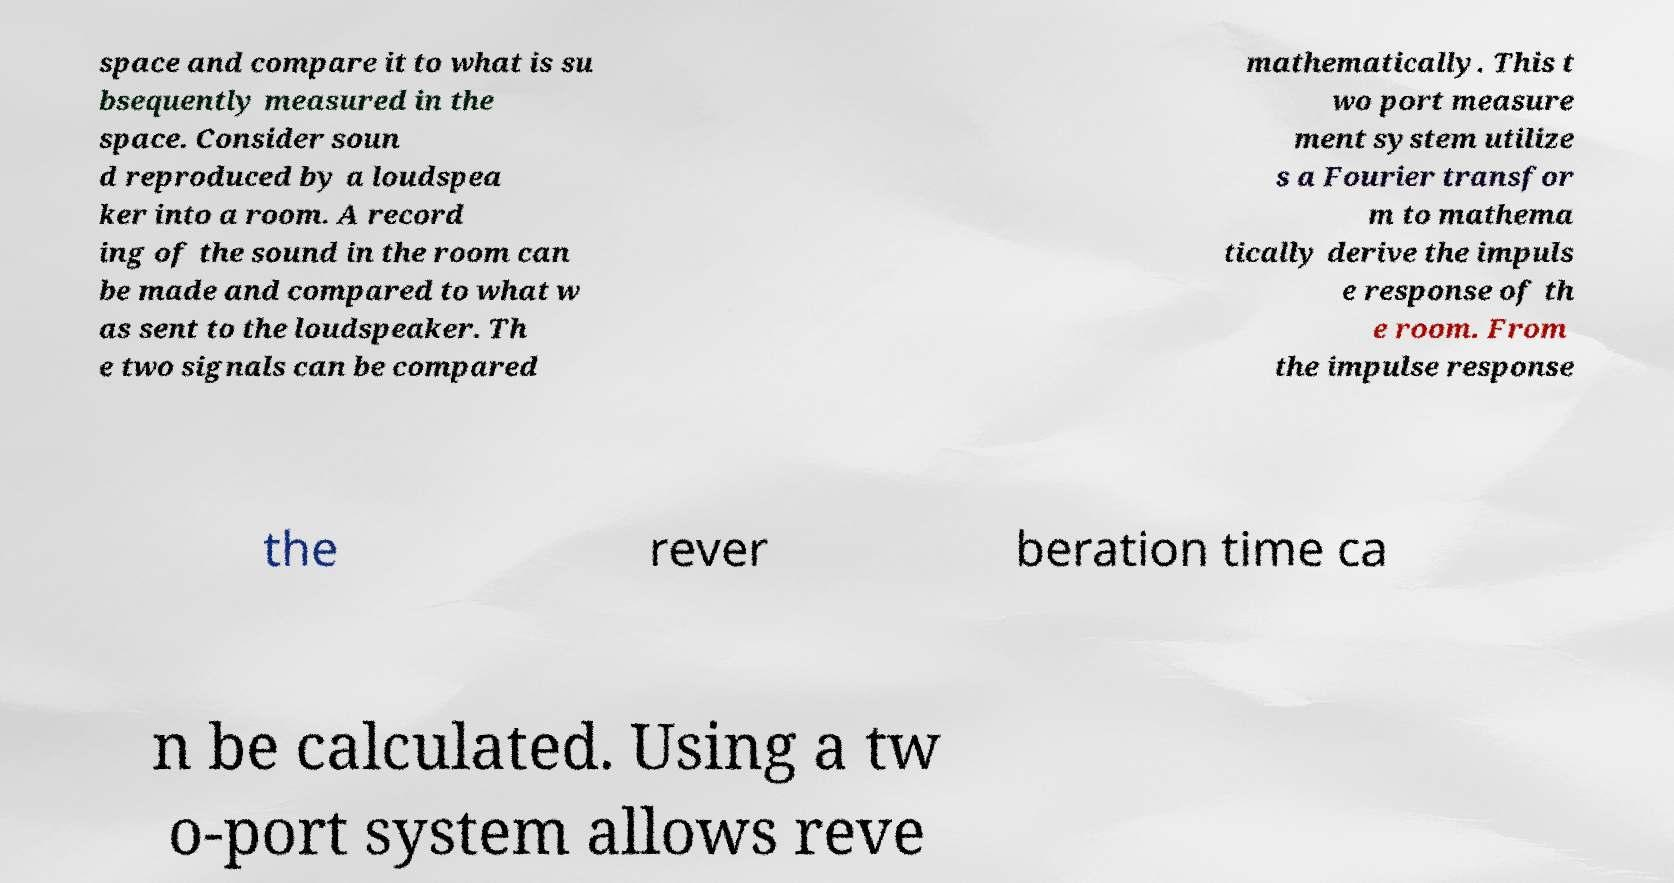Please identify and transcribe the text found in this image. space and compare it to what is su bsequently measured in the space. Consider soun d reproduced by a loudspea ker into a room. A record ing of the sound in the room can be made and compared to what w as sent to the loudspeaker. Th e two signals can be compared mathematically. This t wo port measure ment system utilize s a Fourier transfor m to mathema tically derive the impuls e response of th e room. From the impulse response the rever beration time ca n be calculated. Using a tw o-port system allows reve 